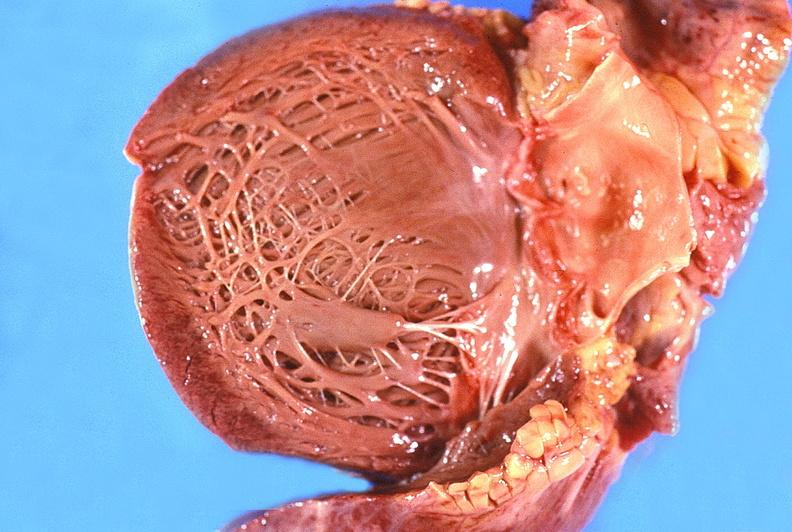where is this?
Answer the question using a single word or phrase. Heart 